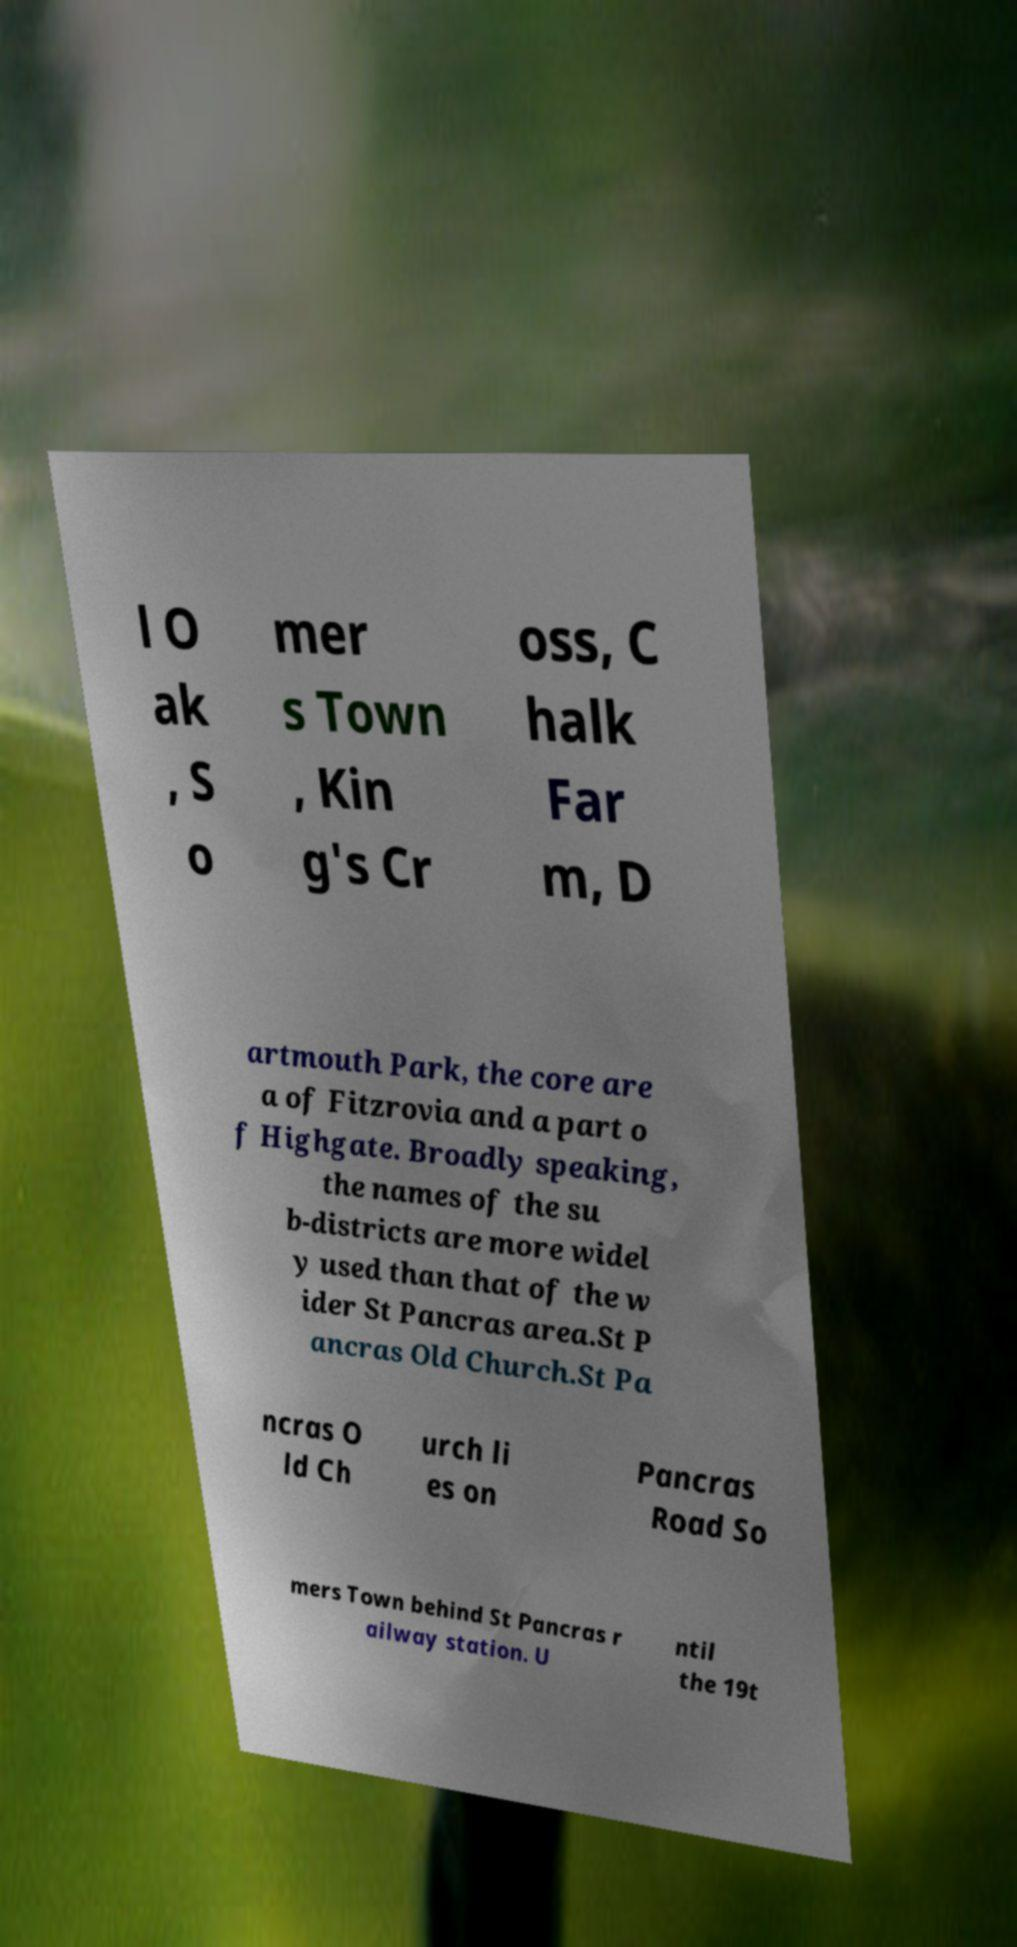For documentation purposes, I need the text within this image transcribed. Could you provide that? l O ak , S o mer s Town , Kin g's Cr oss, C halk Far m, D artmouth Park, the core are a of Fitzrovia and a part o f Highgate. Broadly speaking, the names of the su b-districts are more widel y used than that of the w ider St Pancras area.St P ancras Old Church.St Pa ncras O ld Ch urch li es on Pancras Road So mers Town behind St Pancras r ailway station. U ntil the 19t 